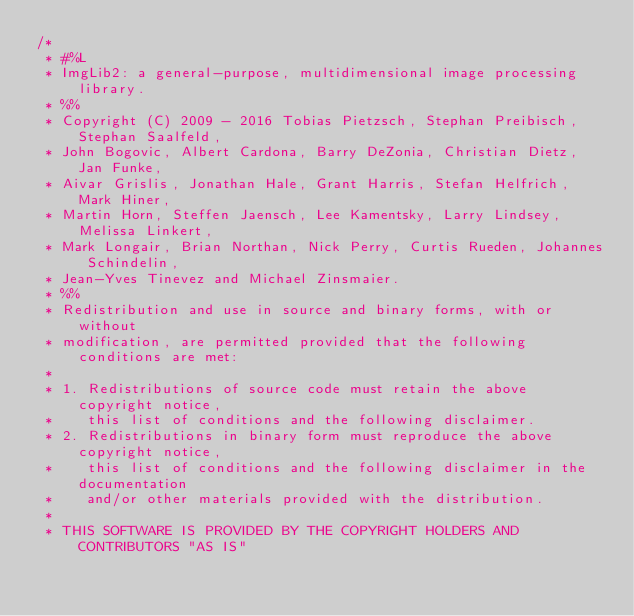<code> <loc_0><loc_0><loc_500><loc_500><_Java_>/*
 * #%L
 * ImgLib2: a general-purpose, multidimensional image processing library.
 * %%
 * Copyright (C) 2009 - 2016 Tobias Pietzsch, Stephan Preibisch, Stephan Saalfeld,
 * John Bogovic, Albert Cardona, Barry DeZonia, Christian Dietz, Jan Funke,
 * Aivar Grislis, Jonathan Hale, Grant Harris, Stefan Helfrich, Mark Hiner,
 * Martin Horn, Steffen Jaensch, Lee Kamentsky, Larry Lindsey, Melissa Linkert,
 * Mark Longair, Brian Northan, Nick Perry, Curtis Rueden, Johannes Schindelin,
 * Jean-Yves Tinevez and Michael Zinsmaier.
 * %%
 * Redistribution and use in source and binary forms, with or without
 * modification, are permitted provided that the following conditions are met:
 * 
 * 1. Redistributions of source code must retain the above copyright notice,
 *    this list of conditions and the following disclaimer.
 * 2. Redistributions in binary form must reproduce the above copyright notice,
 *    this list of conditions and the following disclaimer in the documentation
 *    and/or other materials provided with the distribution.
 * 
 * THIS SOFTWARE IS PROVIDED BY THE COPYRIGHT HOLDERS AND CONTRIBUTORS "AS IS"</code> 